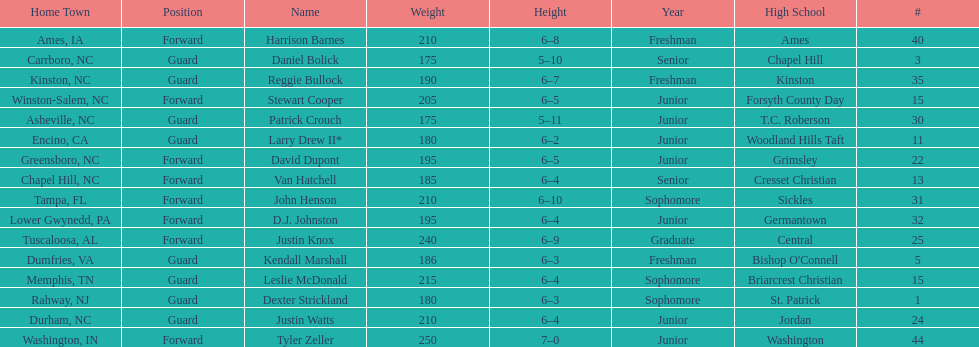How many players play a position other than guard? 8. 